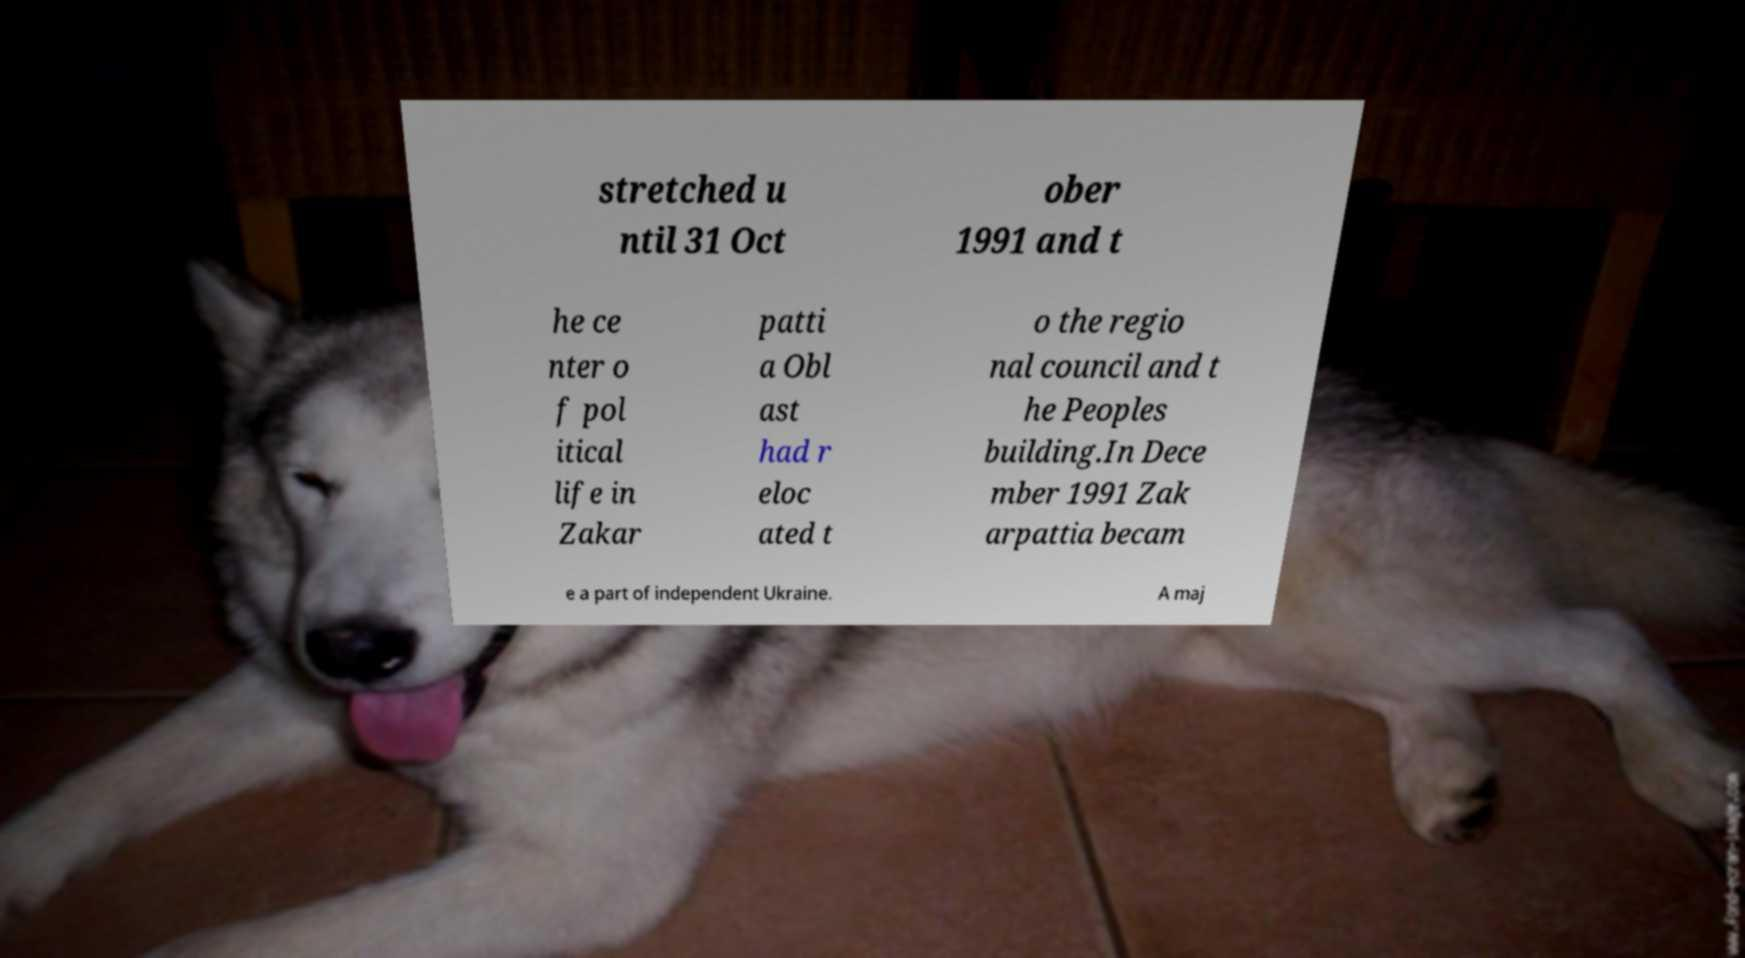For documentation purposes, I need the text within this image transcribed. Could you provide that? stretched u ntil 31 Oct ober 1991 and t he ce nter o f pol itical life in Zakar patti a Obl ast had r eloc ated t o the regio nal council and t he Peoples building.In Dece mber 1991 Zak arpattia becam e a part of independent Ukraine. A maj 